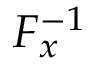<formula> <loc_0><loc_0><loc_500><loc_500>F _ { x } ^ { - 1 }</formula> 